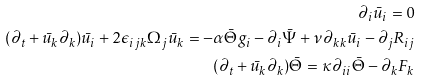Convert formula to latex. <formula><loc_0><loc_0><loc_500><loc_500>\partial _ { i } \bar { u } _ { i } = 0 \\ ( \partial _ { t } + \bar { u } _ { k } \partial _ { k } ) \bar { u } _ { i } + 2 \epsilon _ { i j k } \Omega _ { j } \bar { u } _ { k } = - \alpha \bar { \Theta } g _ { i } - \partial _ { i } \bar { \Psi } + \nu \partial _ { k k } \bar { u } _ { i } - \partial _ { j } R _ { i j } \\ ( \partial _ { t } + \bar { u } _ { k } \partial _ { k } ) \bar { \Theta } = \kappa \partial _ { i i } \bar { \Theta } - \partial _ { k } F _ { k }</formula> 